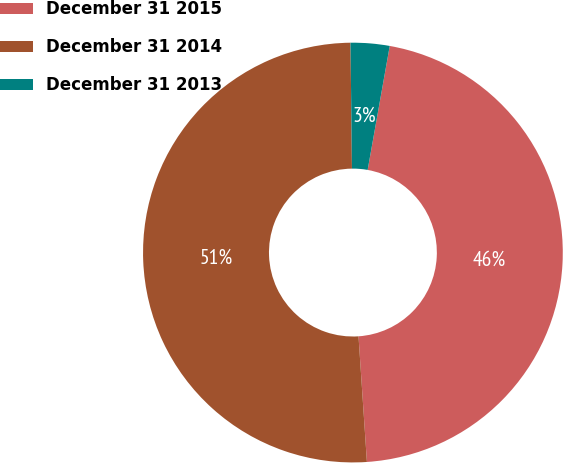Convert chart to OTSL. <chart><loc_0><loc_0><loc_500><loc_500><pie_chart><fcel>December 31 2015<fcel>December 31 2014<fcel>December 31 2013<nl><fcel>46.13%<fcel>50.88%<fcel>2.99%<nl></chart> 